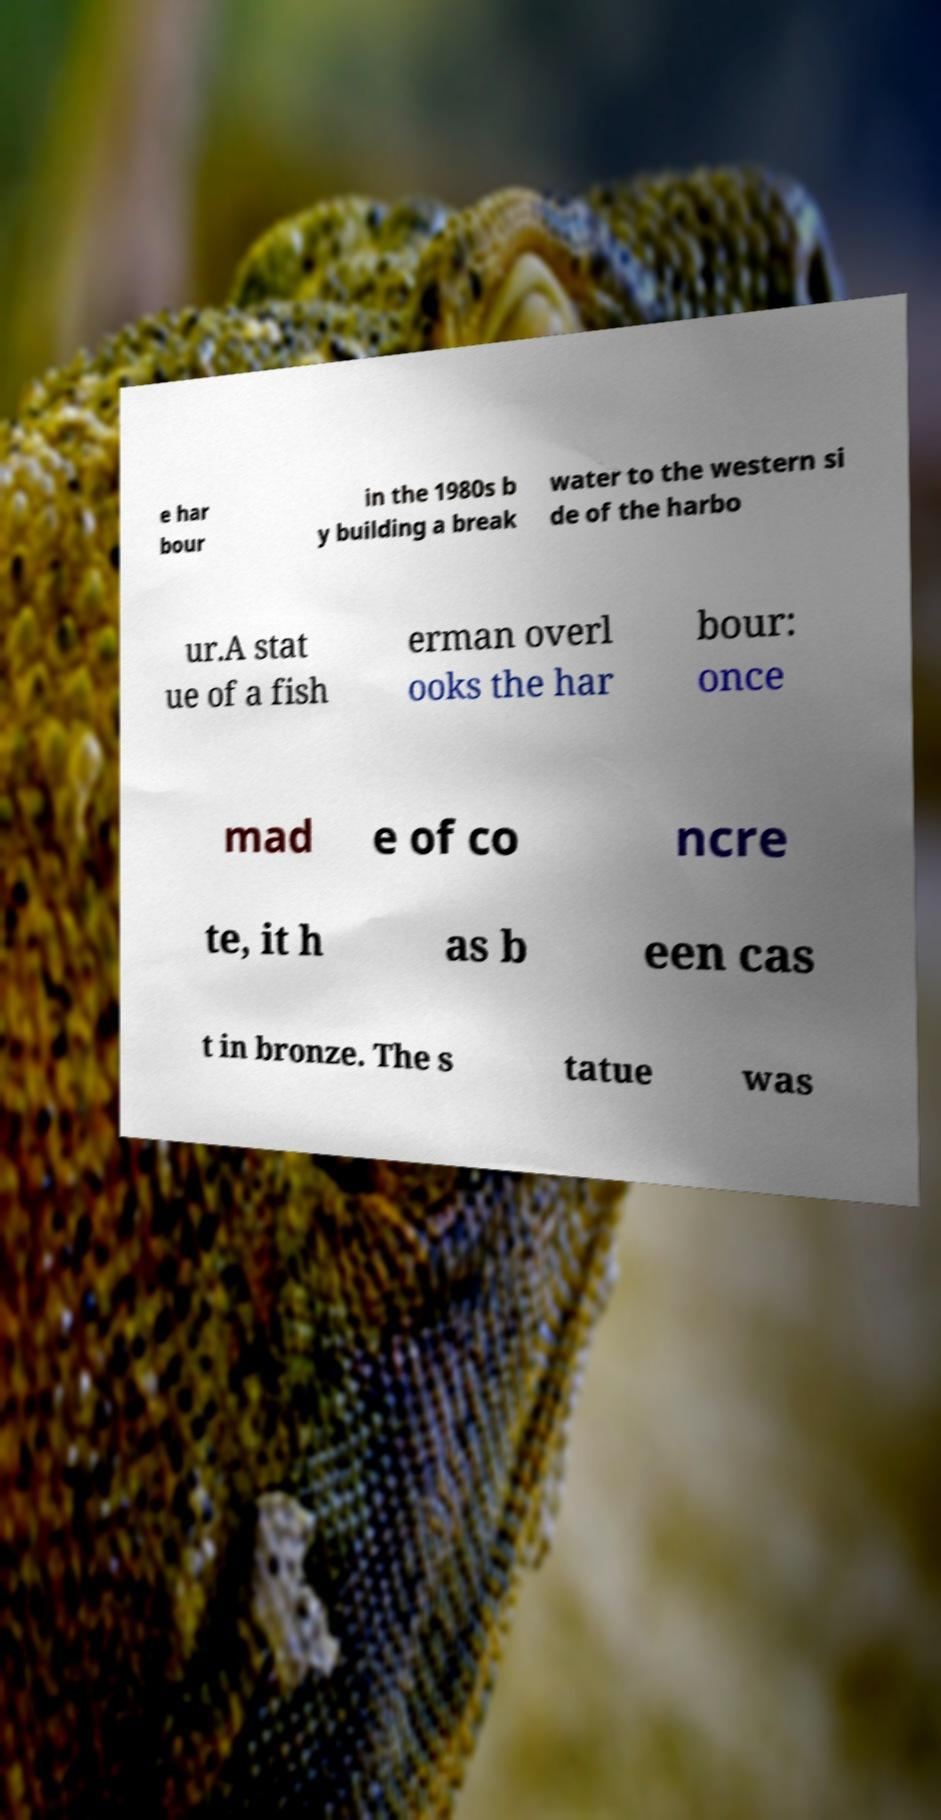There's text embedded in this image that I need extracted. Can you transcribe it verbatim? e har bour in the 1980s b y building a break water to the western si de of the harbo ur.A stat ue of a fish erman overl ooks the har bour: once mad e of co ncre te, it h as b een cas t in bronze. The s tatue was 